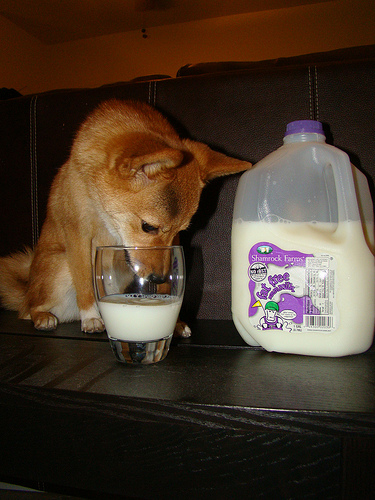<image>
Can you confirm if the milk is behind the dog? No. The milk is not behind the dog. From this viewpoint, the milk appears to be positioned elsewhere in the scene. 